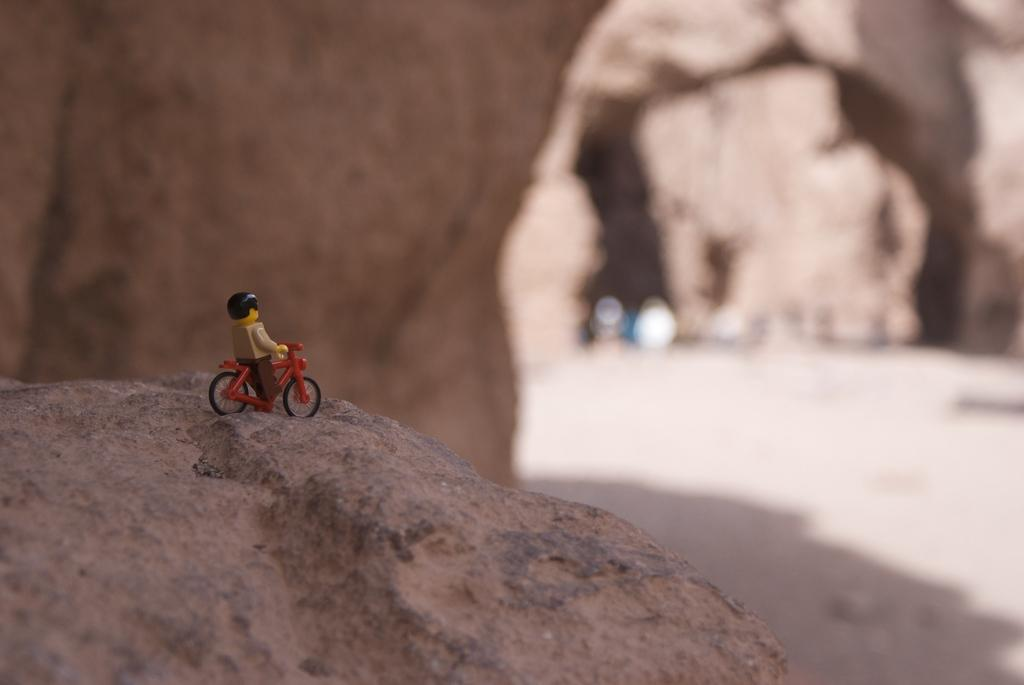What object is in the picture? There is a toy in the picture. Where is the toy located? The toy is on a rock. What can be seen in the background of the picture? There are rocks in the background of the picture. Where is the pipe located in the picture? There is no pipe present in the picture. What type of building can be seen in the background of the picture? There is no building present in the picture; it only features a toy on a rock and rocks in the background. 